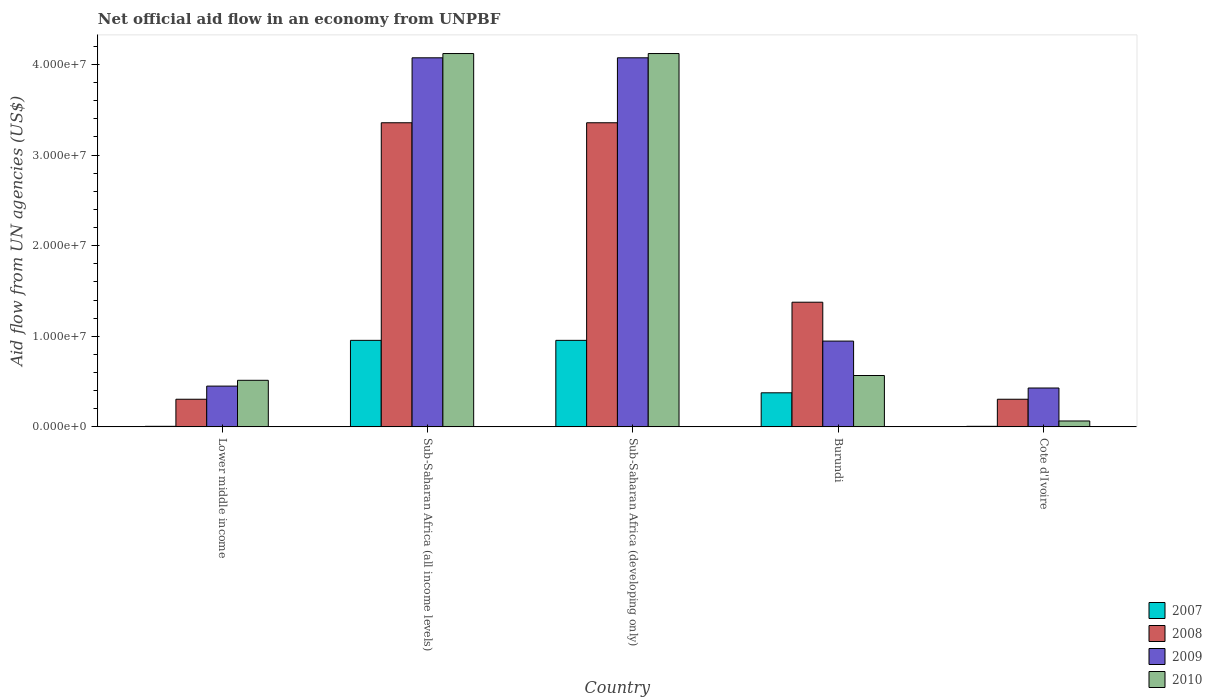Are the number of bars per tick equal to the number of legend labels?
Make the answer very short. Yes. Are the number of bars on each tick of the X-axis equal?
Your answer should be compact. Yes. How many bars are there on the 5th tick from the right?
Make the answer very short. 4. What is the label of the 3rd group of bars from the left?
Your answer should be very brief. Sub-Saharan Africa (developing only). In how many cases, is the number of bars for a given country not equal to the number of legend labels?
Provide a short and direct response. 0. What is the net official aid flow in 2009 in Burundi?
Offer a terse response. 9.47e+06. Across all countries, what is the maximum net official aid flow in 2009?
Your answer should be very brief. 4.07e+07. Across all countries, what is the minimum net official aid flow in 2009?
Provide a short and direct response. 4.29e+06. In which country was the net official aid flow in 2009 maximum?
Give a very brief answer. Sub-Saharan Africa (all income levels). In which country was the net official aid flow in 2010 minimum?
Provide a succinct answer. Cote d'Ivoire. What is the total net official aid flow in 2010 in the graph?
Keep it short and to the point. 9.39e+07. What is the difference between the net official aid flow in 2009 in Lower middle income and that in Sub-Saharan Africa (all income levels)?
Offer a terse response. -3.62e+07. What is the difference between the net official aid flow in 2010 in Burundi and the net official aid flow in 2009 in Lower middle income?
Make the answer very short. 1.17e+06. What is the average net official aid flow in 2010 per country?
Ensure brevity in your answer.  1.88e+07. What is the difference between the net official aid flow of/in 2009 and net official aid flow of/in 2008 in Sub-Saharan Africa (developing only)?
Give a very brief answer. 7.17e+06. In how many countries, is the net official aid flow in 2008 greater than 28000000 US$?
Ensure brevity in your answer.  2. What is the ratio of the net official aid flow in 2008 in Burundi to that in Cote d'Ivoire?
Your answer should be very brief. 4.51. What is the difference between the highest and the second highest net official aid flow in 2008?
Make the answer very short. 1.98e+07. What is the difference between the highest and the lowest net official aid flow in 2007?
Your answer should be compact. 9.49e+06. In how many countries, is the net official aid flow in 2007 greater than the average net official aid flow in 2007 taken over all countries?
Your answer should be very brief. 2. Is it the case that in every country, the sum of the net official aid flow in 2008 and net official aid flow in 2007 is greater than the sum of net official aid flow in 2009 and net official aid flow in 2010?
Offer a very short reply. No. How many bars are there?
Make the answer very short. 20. Are the values on the major ticks of Y-axis written in scientific E-notation?
Offer a very short reply. Yes. Does the graph contain any zero values?
Your answer should be very brief. No. How are the legend labels stacked?
Provide a succinct answer. Vertical. What is the title of the graph?
Keep it short and to the point. Net official aid flow in an economy from UNPBF. Does "2007" appear as one of the legend labels in the graph?
Offer a terse response. Yes. What is the label or title of the Y-axis?
Give a very brief answer. Aid flow from UN agencies (US$). What is the Aid flow from UN agencies (US$) of 2008 in Lower middle income?
Keep it short and to the point. 3.05e+06. What is the Aid flow from UN agencies (US$) of 2009 in Lower middle income?
Provide a succinct answer. 4.50e+06. What is the Aid flow from UN agencies (US$) of 2010 in Lower middle income?
Keep it short and to the point. 5.14e+06. What is the Aid flow from UN agencies (US$) of 2007 in Sub-Saharan Africa (all income levels)?
Keep it short and to the point. 9.55e+06. What is the Aid flow from UN agencies (US$) of 2008 in Sub-Saharan Africa (all income levels)?
Make the answer very short. 3.36e+07. What is the Aid flow from UN agencies (US$) in 2009 in Sub-Saharan Africa (all income levels)?
Provide a short and direct response. 4.07e+07. What is the Aid flow from UN agencies (US$) of 2010 in Sub-Saharan Africa (all income levels)?
Your response must be concise. 4.12e+07. What is the Aid flow from UN agencies (US$) in 2007 in Sub-Saharan Africa (developing only)?
Your answer should be compact. 9.55e+06. What is the Aid flow from UN agencies (US$) in 2008 in Sub-Saharan Africa (developing only)?
Your answer should be compact. 3.36e+07. What is the Aid flow from UN agencies (US$) of 2009 in Sub-Saharan Africa (developing only)?
Make the answer very short. 4.07e+07. What is the Aid flow from UN agencies (US$) of 2010 in Sub-Saharan Africa (developing only)?
Provide a succinct answer. 4.12e+07. What is the Aid flow from UN agencies (US$) of 2007 in Burundi?
Ensure brevity in your answer.  3.76e+06. What is the Aid flow from UN agencies (US$) in 2008 in Burundi?
Keep it short and to the point. 1.38e+07. What is the Aid flow from UN agencies (US$) in 2009 in Burundi?
Ensure brevity in your answer.  9.47e+06. What is the Aid flow from UN agencies (US$) of 2010 in Burundi?
Make the answer very short. 5.67e+06. What is the Aid flow from UN agencies (US$) in 2008 in Cote d'Ivoire?
Provide a succinct answer. 3.05e+06. What is the Aid flow from UN agencies (US$) in 2009 in Cote d'Ivoire?
Your answer should be compact. 4.29e+06. What is the Aid flow from UN agencies (US$) of 2010 in Cote d'Ivoire?
Give a very brief answer. 6.50e+05. Across all countries, what is the maximum Aid flow from UN agencies (US$) in 2007?
Make the answer very short. 9.55e+06. Across all countries, what is the maximum Aid flow from UN agencies (US$) of 2008?
Your answer should be very brief. 3.36e+07. Across all countries, what is the maximum Aid flow from UN agencies (US$) of 2009?
Make the answer very short. 4.07e+07. Across all countries, what is the maximum Aid flow from UN agencies (US$) in 2010?
Ensure brevity in your answer.  4.12e+07. Across all countries, what is the minimum Aid flow from UN agencies (US$) in 2008?
Ensure brevity in your answer.  3.05e+06. Across all countries, what is the minimum Aid flow from UN agencies (US$) of 2009?
Provide a succinct answer. 4.29e+06. Across all countries, what is the minimum Aid flow from UN agencies (US$) of 2010?
Make the answer very short. 6.50e+05. What is the total Aid flow from UN agencies (US$) of 2007 in the graph?
Ensure brevity in your answer.  2.30e+07. What is the total Aid flow from UN agencies (US$) in 2008 in the graph?
Your response must be concise. 8.70e+07. What is the total Aid flow from UN agencies (US$) in 2009 in the graph?
Your answer should be very brief. 9.97e+07. What is the total Aid flow from UN agencies (US$) in 2010 in the graph?
Ensure brevity in your answer.  9.39e+07. What is the difference between the Aid flow from UN agencies (US$) in 2007 in Lower middle income and that in Sub-Saharan Africa (all income levels)?
Provide a short and direct response. -9.49e+06. What is the difference between the Aid flow from UN agencies (US$) in 2008 in Lower middle income and that in Sub-Saharan Africa (all income levels)?
Your answer should be compact. -3.05e+07. What is the difference between the Aid flow from UN agencies (US$) in 2009 in Lower middle income and that in Sub-Saharan Africa (all income levels)?
Provide a short and direct response. -3.62e+07. What is the difference between the Aid flow from UN agencies (US$) in 2010 in Lower middle income and that in Sub-Saharan Africa (all income levels)?
Keep it short and to the point. -3.61e+07. What is the difference between the Aid flow from UN agencies (US$) in 2007 in Lower middle income and that in Sub-Saharan Africa (developing only)?
Keep it short and to the point. -9.49e+06. What is the difference between the Aid flow from UN agencies (US$) of 2008 in Lower middle income and that in Sub-Saharan Africa (developing only)?
Your answer should be compact. -3.05e+07. What is the difference between the Aid flow from UN agencies (US$) of 2009 in Lower middle income and that in Sub-Saharan Africa (developing only)?
Your answer should be compact. -3.62e+07. What is the difference between the Aid flow from UN agencies (US$) of 2010 in Lower middle income and that in Sub-Saharan Africa (developing only)?
Your answer should be very brief. -3.61e+07. What is the difference between the Aid flow from UN agencies (US$) of 2007 in Lower middle income and that in Burundi?
Make the answer very short. -3.70e+06. What is the difference between the Aid flow from UN agencies (US$) of 2008 in Lower middle income and that in Burundi?
Provide a succinct answer. -1.07e+07. What is the difference between the Aid flow from UN agencies (US$) of 2009 in Lower middle income and that in Burundi?
Your answer should be very brief. -4.97e+06. What is the difference between the Aid flow from UN agencies (US$) of 2010 in Lower middle income and that in Burundi?
Your answer should be very brief. -5.30e+05. What is the difference between the Aid flow from UN agencies (US$) of 2007 in Lower middle income and that in Cote d'Ivoire?
Provide a short and direct response. 0. What is the difference between the Aid flow from UN agencies (US$) of 2008 in Lower middle income and that in Cote d'Ivoire?
Offer a very short reply. 0. What is the difference between the Aid flow from UN agencies (US$) of 2010 in Lower middle income and that in Cote d'Ivoire?
Provide a short and direct response. 4.49e+06. What is the difference between the Aid flow from UN agencies (US$) of 2007 in Sub-Saharan Africa (all income levels) and that in Sub-Saharan Africa (developing only)?
Offer a terse response. 0. What is the difference between the Aid flow from UN agencies (US$) in 2008 in Sub-Saharan Africa (all income levels) and that in Sub-Saharan Africa (developing only)?
Offer a terse response. 0. What is the difference between the Aid flow from UN agencies (US$) of 2007 in Sub-Saharan Africa (all income levels) and that in Burundi?
Your answer should be compact. 5.79e+06. What is the difference between the Aid flow from UN agencies (US$) of 2008 in Sub-Saharan Africa (all income levels) and that in Burundi?
Offer a terse response. 1.98e+07. What is the difference between the Aid flow from UN agencies (US$) in 2009 in Sub-Saharan Africa (all income levels) and that in Burundi?
Offer a terse response. 3.13e+07. What is the difference between the Aid flow from UN agencies (US$) in 2010 in Sub-Saharan Africa (all income levels) and that in Burundi?
Ensure brevity in your answer.  3.55e+07. What is the difference between the Aid flow from UN agencies (US$) of 2007 in Sub-Saharan Africa (all income levels) and that in Cote d'Ivoire?
Offer a very short reply. 9.49e+06. What is the difference between the Aid flow from UN agencies (US$) of 2008 in Sub-Saharan Africa (all income levels) and that in Cote d'Ivoire?
Make the answer very short. 3.05e+07. What is the difference between the Aid flow from UN agencies (US$) in 2009 in Sub-Saharan Africa (all income levels) and that in Cote d'Ivoire?
Offer a very short reply. 3.64e+07. What is the difference between the Aid flow from UN agencies (US$) in 2010 in Sub-Saharan Africa (all income levels) and that in Cote d'Ivoire?
Offer a very short reply. 4.06e+07. What is the difference between the Aid flow from UN agencies (US$) in 2007 in Sub-Saharan Africa (developing only) and that in Burundi?
Your answer should be compact. 5.79e+06. What is the difference between the Aid flow from UN agencies (US$) in 2008 in Sub-Saharan Africa (developing only) and that in Burundi?
Your response must be concise. 1.98e+07. What is the difference between the Aid flow from UN agencies (US$) of 2009 in Sub-Saharan Africa (developing only) and that in Burundi?
Offer a terse response. 3.13e+07. What is the difference between the Aid flow from UN agencies (US$) in 2010 in Sub-Saharan Africa (developing only) and that in Burundi?
Give a very brief answer. 3.55e+07. What is the difference between the Aid flow from UN agencies (US$) in 2007 in Sub-Saharan Africa (developing only) and that in Cote d'Ivoire?
Give a very brief answer. 9.49e+06. What is the difference between the Aid flow from UN agencies (US$) in 2008 in Sub-Saharan Africa (developing only) and that in Cote d'Ivoire?
Keep it short and to the point. 3.05e+07. What is the difference between the Aid flow from UN agencies (US$) of 2009 in Sub-Saharan Africa (developing only) and that in Cote d'Ivoire?
Make the answer very short. 3.64e+07. What is the difference between the Aid flow from UN agencies (US$) of 2010 in Sub-Saharan Africa (developing only) and that in Cote d'Ivoire?
Provide a short and direct response. 4.06e+07. What is the difference between the Aid flow from UN agencies (US$) in 2007 in Burundi and that in Cote d'Ivoire?
Offer a terse response. 3.70e+06. What is the difference between the Aid flow from UN agencies (US$) of 2008 in Burundi and that in Cote d'Ivoire?
Give a very brief answer. 1.07e+07. What is the difference between the Aid flow from UN agencies (US$) in 2009 in Burundi and that in Cote d'Ivoire?
Make the answer very short. 5.18e+06. What is the difference between the Aid flow from UN agencies (US$) of 2010 in Burundi and that in Cote d'Ivoire?
Provide a succinct answer. 5.02e+06. What is the difference between the Aid flow from UN agencies (US$) in 2007 in Lower middle income and the Aid flow from UN agencies (US$) in 2008 in Sub-Saharan Africa (all income levels)?
Offer a very short reply. -3.35e+07. What is the difference between the Aid flow from UN agencies (US$) of 2007 in Lower middle income and the Aid flow from UN agencies (US$) of 2009 in Sub-Saharan Africa (all income levels)?
Offer a terse response. -4.07e+07. What is the difference between the Aid flow from UN agencies (US$) in 2007 in Lower middle income and the Aid flow from UN agencies (US$) in 2010 in Sub-Saharan Africa (all income levels)?
Offer a very short reply. -4.12e+07. What is the difference between the Aid flow from UN agencies (US$) of 2008 in Lower middle income and the Aid flow from UN agencies (US$) of 2009 in Sub-Saharan Africa (all income levels)?
Give a very brief answer. -3.77e+07. What is the difference between the Aid flow from UN agencies (US$) of 2008 in Lower middle income and the Aid flow from UN agencies (US$) of 2010 in Sub-Saharan Africa (all income levels)?
Offer a very short reply. -3.82e+07. What is the difference between the Aid flow from UN agencies (US$) in 2009 in Lower middle income and the Aid flow from UN agencies (US$) in 2010 in Sub-Saharan Africa (all income levels)?
Your response must be concise. -3.67e+07. What is the difference between the Aid flow from UN agencies (US$) in 2007 in Lower middle income and the Aid flow from UN agencies (US$) in 2008 in Sub-Saharan Africa (developing only)?
Your answer should be very brief. -3.35e+07. What is the difference between the Aid flow from UN agencies (US$) of 2007 in Lower middle income and the Aid flow from UN agencies (US$) of 2009 in Sub-Saharan Africa (developing only)?
Offer a very short reply. -4.07e+07. What is the difference between the Aid flow from UN agencies (US$) of 2007 in Lower middle income and the Aid flow from UN agencies (US$) of 2010 in Sub-Saharan Africa (developing only)?
Your answer should be very brief. -4.12e+07. What is the difference between the Aid flow from UN agencies (US$) of 2008 in Lower middle income and the Aid flow from UN agencies (US$) of 2009 in Sub-Saharan Africa (developing only)?
Your answer should be very brief. -3.77e+07. What is the difference between the Aid flow from UN agencies (US$) in 2008 in Lower middle income and the Aid flow from UN agencies (US$) in 2010 in Sub-Saharan Africa (developing only)?
Provide a succinct answer. -3.82e+07. What is the difference between the Aid flow from UN agencies (US$) of 2009 in Lower middle income and the Aid flow from UN agencies (US$) of 2010 in Sub-Saharan Africa (developing only)?
Your response must be concise. -3.67e+07. What is the difference between the Aid flow from UN agencies (US$) in 2007 in Lower middle income and the Aid flow from UN agencies (US$) in 2008 in Burundi?
Offer a terse response. -1.37e+07. What is the difference between the Aid flow from UN agencies (US$) in 2007 in Lower middle income and the Aid flow from UN agencies (US$) in 2009 in Burundi?
Offer a very short reply. -9.41e+06. What is the difference between the Aid flow from UN agencies (US$) in 2007 in Lower middle income and the Aid flow from UN agencies (US$) in 2010 in Burundi?
Provide a succinct answer. -5.61e+06. What is the difference between the Aid flow from UN agencies (US$) of 2008 in Lower middle income and the Aid flow from UN agencies (US$) of 2009 in Burundi?
Your answer should be very brief. -6.42e+06. What is the difference between the Aid flow from UN agencies (US$) of 2008 in Lower middle income and the Aid flow from UN agencies (US$) of 2010 in Burundi?
Keep it short and to the point. -2.62e+06. What is the difference between the Aid flow from UN agencies (US$) of 2009 in Lower middle income and the Aid flow from UN agencies (US$) of 2010 in Burundi?
Provide a short and direct response. -1.17e+06. What is the difference between the Aid flow from UN agencies (US$) in 2007 in Lower middle income and the Aid flow from UN agencies (US$) in 2008 in Cote d'Ivoire?
Your answer should be compact. -2.99e+06. What is the difference between the Aid flow from UN agencies (US$) of 2007 in Lower middle income and the Aid flow from UN agencies (US$) of 2009 in Cote d'Ivoire?
Provide a succinct answer. -4.23e+06. What is the difference between the Aid flow from UN agencies (US$) of 2007 in Lower middle income and the Aid flow from UN agencies (US$) of 2010 in Cote d'Ivoire?
Offer a very short reply. -5.90e+05. What is the difference between the Aid flow from UN agencies (US$) of 2008 in Lower middle income and the Aid flow from UN agencies (US$) of 2009 in Cote d'Ivoire?
Your answer should be compact. -1.24e+06. What is the difference between the Aid flow from UN agencies (US$) of 2008 in Lower middle income and the Aid flow from UN agencies (US$) of 2010 in Cote d'Ivoire?
Provide a short and direct response. 2.40e+06. What is the difference between the Aid flow from UN agencies (US$) of 2009 in Lower middle income and the Aid flow from UN agencies (US$) of 2010 in Cote d'Ivoire?
Offer a terse response. 3.85e+06. What is the difference between the Aid flow from UN agencies (US$) in 2007 in Sub-Saharan Africa (all income levels) and the Aid flow from UN agencies (US$) in 2008 in Sub-Saharan Africa (developing only)?
Make the answer very short. -2.40e+07. What is the difference between the Aid flow from UN agencies (US$) in 2007 in Sub-Saharan Africa (all income levels) and the Aid flow from UN agencies (US$) in 2009 in Sub-Saharan Africa (developing only)?
Ensure brevity in your answer.  -3.12e+07. What is the difference between the Aid flow from UN agencies (US$) in 2007 in Sub-Saharan Africa (all income levels) and the Aid flow from UN agencies (US$) in 2010 in Sub-Saharan Africa (developing only)?
Your answer should be compact. -3.17e+07. What is the difference between the Aid flow from UN agencies (US$) in 2008 in Sub-Saharan Africa (all income levels) and the Aid flow from UN agencies (US$) in 2009 in Sub-Saharan Africa (developing only)?
Make the answer very short. -7.17e+06. What is the difference between the Aid flow from UN agencies (US$) in 2008 in Sub-Saharan Africa (all income levels) and the Aid flow from UN agencies (US$) in 2010 in Sub-Saharan Africa (developing only)?
Ensure brevity in your answer.  -7.64e+06. What is the difference between the Aid flow from UN agencies (US$) in 2009 in Sub-Saharan Africa (all income levels) and the Aid flow from UN agencies (US$) in 2010 in Sub-Saharan Africa (developing only)?
Keep it short and to the point. -4.70e+05. What is the difference between the Aid flow from UN agencies (US$) of 2007 in Sub-Saharan Africa (all income levels) and the Aid flow from UN agencies (US$) of 2008 in Burundi?
Keep it short and to the point. -4.21e+06. What is the difference between the Aid flow from UN agencies (US$) of 2007 in Sub-Saharan Africa (all income levels) and the Aid flow from UN agencies (US$) of 2010 in Burundi?
Keep it short and to the point. 3.88e+06. What is the difference between the Aid flow from UN agencies (US$) of 2008 in Sub-Saharan Africa (all income levels) and the Aid flow from UN agencies (US$) of 2009 in Burundi?
Provide a short and direct response. 2.41e+07. What is the difference between the Aid flow from UN agencies (US$) of 2008 in Sub-Saharan Africa (all income levels) and the Aid flow from UN agencies (US$) of 2010 in Burundi?
Provide a succinct answer. 2.79e+07. What is the difference between the Aid flow from UN agencies (US$) of 2009 in Sub-Saharan Africa (all income levels) and the Aid flow from UN agencies (US$) of 2010 in Burundi?
Offer a terse response. 3.51e+07. What is the difference between the Aid flow from UN agencies (US$) of 2007 in Sub-Saharan Africa (all income levels) and the Aid flow from UN agencies (US$) of 2008 in Cote d'Ivoire?
Provide a short and direct response. 6.50e+06. What is the difference between the Aid flow from UN agencies (US$) in 2007 in Sub-Saharan Africa (all income levels) and the Aid flow from UN agencies (US$) in 2009 in Cote d'Ivoire?
Keep it short and to the point. 5.26e+06. What is the difference between the Aid flow from UN agencies (US$) in 2007 in Sub-Saharan Africa (all income levels) and the Aid flow from UN agencies (US$) in 2010 in Cote d'Ivoire?
Ensure brevity in your answer.  8.90e+06. What is the difference between the Aid flow from UN agencies (US$) of 2008 in Sub-Saharan Africa (all income levels) and the Aid flow from UN agencies (US$) of 2009 in Cote d'Ivoire?
Provide a succinct answer. 2.93e+07. What is the difference between the Aid flow from UN agencies (US$) in 2008 in Sub-Saharan Africa (all income levels) and the Aid flow from UN agencies (US$) in 2010 in Cote d'Ivoire?
Make the answer very short. 3.29e+07. What is the difference between the Aid flow from UN agencies (US$) of 2009 in Sub-Saharan Africa (all income levels) and the Aid flow from UN agencies (US$) of 2010 in Cote d'Ivoire?
Give a very brief answer. 4.01e+07. What is the difference between the Aid flow from UN agencies (US$) of 2007 in Sub-Saharan Africa (developing only) and the Aid flow from UN agencies (US$) of 2008 in Burundi?
Your answer should be very brief. -4.21e+06. What is the difference between the Aid flow from UN agencies (US$) of 2007 in Sub-Saharan Africa (developing only) and the Aid flow from UN agencies (US$) of 2009 in Burundi?
Keep it short and to the point. 8.00e+04. What is the difference between the Aid flow from UN agencies (US$) of 2007 in Sub-Saharan Africa (developing only) and the Aid flow from UN agencies (US$) of 2010 in Burundi?
Offer a terse response. 3.88e+06. What is the difference between the Aid flow from UN agencies (US$) of 2008 in Sub-Saharan Africa (developing only) and the Aid flow from UN agencies (US$) of 2009 in Burundi?
Offer a very short reply. 2.41e+07. What is the difference between the Aid flow from UN agencies (US$) in 2008 in Sub-Saharan Africa (developing only) and the Aid flow from UN agencies (US$) in 2010 in Burundi?
Keep it short and to the point. 2.79e+07. What is the difference between the Aid flow from UN agencies (US$) in 2009 in Sub-Saharan Africa (developing only) and the Aid flow from UN agencies (US$) in 2010 in Burundi?
Your answer should be compact. 3.51e+07. What is the difference between the Aid flow from UN agencies (US$) in 2007 in Sub-Saharan Africa (developing only) and the Aid flow from UN agencies (US$) in 2008 in Cote d'Ivoire?
Your response must be concise. 6.50e+06. What is the difference between the Aid flow from UN agencies (US$) of 2007 in Sub-Saharan Africa (developing only) and the Aid flow from UN agencies (US$) of 2009 in Cote d'Ivoire?
Your answer should be very brief. 5.26e+06. What is the difference between the Aid flow from UN agencies (US$) in 2007 in Sub-Saharan Africa (developing only) and the Aid flow from UN agencies (US$) in 2010 in Cote d'Ivoire?
Ensure brevity in your answer.  8.90e+06. What is the difference between the Aid flow from UN agencies (US$) of 2008 in Sub-Saharan Africa (developing only) and the Aid flow from UN agencies (US$) of 2009 in Cote d'Ivoire?
Give a very brief answer. 2.93e+07. What is the difference between the Aid flow from UN agencies (US$) in 2008 in Sub-Saharan Africa (developing only) and the Aid flow from UN agencies (US$) in 2010 in Cote d'Ivoire?
Keep it short and to the point. 3.29e+07. What is the difference between the Aid flow from UN agencies (US$) of 2009 in Sub-Saharan Africa (developing only) and the Aid flow from UN agencies (US$) of 2010 in Cote d'Ivoire?
Give a very brief answer. 4.01e+07. What is the difference between the Aid flow from UN agencies (US$) of 2007 in Burundi and the Aid flow from UN agencies (US$) of 2008 in Cote d'Ivoire?
Provide a short and direct response. 7.10e+05. What is the difference between the Aid flow from UN agencies (US$) of 2007 in Burundi and the Aid flow from UN agencies (US$) of 2009 in Cote d'Ivoire?
Provide a succinct answer. -5.30e+05. What is the difference between the Aid flow from UN agencies (US$) in 2007 in Burundi and the Aid flow from UN agencies (US$) in 2010 in Cote d'Ivoire?
Offer a terse response. 3.11e+06. What is the difference between the Aid flow from UN agencies (US$) of 2008 in Burundi and the Aid flow from UN agencies (US$) of 2009 in Cote d'Ivoire?
Provide a succinct answer. 9.47e+06. What is the difference between the Aid flow from UN agencies (US$) in 2008 in Burundi and the Aid flow from UN agencies (US$) in 2010 in Cote d'Ivoire?
Keep it short and to the point. 1.31e+07. What is the difference between the Aid flow from UN agencies (US$) of 2009 in Burundi and the Aid flow from UN agencies (US$) of 2010 in Cote d'Ivoire?
Your answer should be compact. 8.82e+06. What is the average Aid flow from UN agencies (US$) in 2007 per country?
Keep it short and to the point. 4.60e+06. What is the average Aid flow from UN agencies (US$) of 2008 per country?
Offer a very short reply. 1.74e+07. What is the average Aid flow from UN agencies (US$) in 2009 per country?
Provide a short and direct response. 1.99e+07. What is the average Aid flow from UN agencies (US$) of 2010 per country?
Provide a short and direct response. 1.88e+07. What is the difference between the Aid flow from UN agencies (US$) of 2007 and Aid flow from UN agencies (US$) of 2008 in Lower middle income?
Keep it short and to the point. -2.99e+06. What is the difference between the Aid flow from UN agencies (US$) in 2007 and Aid flow from UN agencies (US$) in 2009 in Lower middle income?
Offer a very short reply. -4.44e+06. What is the difference between the Aid flow from UN agencies (US$) in 2007 and Aid flow from UN agencies (US$) in 2010 in Lower middle income?
Ensure brevity in your answer.  -5.08e+06. What is the difference between the Aid flow from UN agencies (US$) of 2008 and Aid flow from UN agencies (US$) of 2009 in Lower middle income?
Provide a short and direct response. -1.45e+06. What is the difference between the Aid flow from UN agencies (US$) in 2008 and Aid flow from UN agencies (US$) in 2010 in Lower middle income?
Provide a succinct answer. -2.09e+06. What is the difference between the Aid flow from UN agencies (US$) in 2009 and Aid flow from UN agencies (US$) in 2010 in Lower middle income?
Give a very brief answer. -6.40e+05. What is the difference between the Aid flow from UN agencies (US$) of 2007 and Aid flow from UN agencies (US$) of 2008 in Sub-Saharan Africa (all income levels)?
Offer a terse response. -2.40e+07. What is the difference between the Aid flow from UN agencies (US$) of 2007 and Aid flow from UN agencies (US$) of 2009 in Sub-Saharan Africa (all income levels)?
Make the answer very short. -3.12e+07. What is the difference between the Aid flow from UN agencies (US$) of 2007 and Aid flow from UN agencies (US$) of 2010 in Sub-Saharan Africa (all income levels)?
Your answer should be compact. -3.17e+07. What is the difference between the Aid flow from UN agencies (US$) of 2008 and Aid flow from UN agencies (US$) of 2009 in Sub-Saharan Africa (all income levels)?
Make the answer very short. -7.17e+06. What is the difference between the Aid flow from UN agencies (US$) of 2008 and Aid flow from UN agencies (US$) of 2010 in Sub-Saharan Africa (all income levels)?
Provide a short and direct response. -7.64e+06. What is the difference between the Aid flow from UN agencies (US$) of 2009 and Aid flow from UN agencies (US$) of 2010 in Sub-Saharan Africa (all income levels)?
Ensure brevity in your answer.  -4.70e+05. What is the difference between the Aid flow from UN agencies (US$) in 2007 and Aid flow from UN agencies (US$) in 2008 in Sub-Saharan Africa (developing only)?
Your answer should be compact. -2.40e+07. What is the difference between the Aid flow from UN agencies (US$) in 2007 and Aid flow from UN agencies (US$) in 2009 in Sub-Saharan Africa (developing only)?
Make the answer very short. -3.12e+07. What is the difference between the Aid flow from UN agencies (US$) of 2007 and Aid flow from UN agencies (US$) of 2010 in Sub-Saharan Africa (developing only)?
Provide a succinct answer. -3.17e+07. What is the difference between the Aid flow from UN agencies (US$) in 2008 and Aid flow from UN agencies (US$) in 2009 in Sub-Saharan Africa (developing only)?
Your response must be concise. -7.17e+06. What is the difference between the Aid flow from UN agencies (US$) of 2008 and Aid flow from UN agencies (US$) of 2010 in Sub-Saharan Africa (developing only)?
Make the answer very short. -7.64e+06. What is the difference between the Aid flow from UN agencies (US$) in 2009 and Aid flow from UN agencies (US$) in 2010 in Sub-Saharan Africa (developing only)?
Offer a terse response. -4.70e+05. What is the difference between the Aid flow from UN agencies (US$) in 2007 and Aid flow from UN agencies (US$) in 2008 in Burundi?
Give a very brief answer. -1.00e+07. What is the difference between the Aid flow from UN agencies (US$) in 2007 and Aid flow from UN agencies (US$) in 2009 in Burundi?
Your response must be concise. -5.71e+06. What is the difference between the Aid flow from UN agencies (US$) of 2007 and Aid flow from UN agencies (US$) of 2010 in Burundi?
Make the answer very short. -1.91e+06. What is the difference between the Aid flow from UN agencies (US$) of 2008 and Aid flow from UN agencies (US$) of 2009 in Burundi?
Offer a terse response. 4.29e+06. What is the difference between the Aid flow from UN agencies (US$) of 2008 and Aid flow from UN agencies (US$) of 2010 in Burundi?
Make the answer very short. 8.09e+06. What is the difference between the Aid flow from UN agencies (US$) in 2009 and Aid flow from UN agencies (US$) in 2010 in Burundi?
Provide a short and direct response. 3.80e+06. What is the difference between the Aid flow from UN agencies (US$) in 2007 and Aid flow from UN agencies (US$) in 2008 in Cote d'Ivoire?
Offer a terse response. -2.99e+06. What is the difference between the Aid flow from UN agencies (US$) of 2007 and Aid flow from UN agencies (US$) of 2009 in Cote d'Ivoire?
Provide a succinct answer. -4.23e+06. What is the difference between the Aid flow from UN agencies (US$) of 2007 and Aid flow from UN agencies (US$) of 2010 in Cote d'Ivoire?
Provide a short and direct response. -5.90e+05. What is the difference between the Aid flow from UN agencies (US$) in 2008 and Aid flow from UN agencies (US$) in 2009 in Cote d'Ivoire?
Offer a very short reply. -1.24e+06. What is the difference between the Aid flow from UN agencies (US$) of 2008 and Aid flow from UN agencies (US$) of 2010 in Cote d'Ivoire?
Offer a very short reply. 2.40e+06. What is the difference between the Aid flow from UN agencies (US$) of 2009 and Aid flow from UN agencies (US$) of 2010 in Cote d'Ivoire?
Make the answer very short. 3.64e+06. What is the ratio of the Aid flow from UN agencies (US$) in 2007 in Lower middle income to that in Sub-Saharan Africa (all income levels)?
Keep it short and to the point. 0.01. What is the ratio of the Aid flow from UN agencies (US$) of 2008 in Lower middle income to that in Sub-Saharan Africa (all income levels)?
Your response must be concise. 0.09. What is the ratio of the Aid flow from UN agencies (US$) of 2009 in Lower middle income to that in Sub-Saharan Africa (all income levels)?
Offer a very short reply. 0.11. What is the ratio of the Aid flow from UN agencies (US$) in 2010 in Lower middle income to that in Sub-Saharan Africa (all income levels)?
Offer a terse response. 0.12. What is the ratio of the Aid flow from UN agencies (US$) of 2007 in Lower middle income to that in Sub-Saharan Africa (developing only)?
Ensure brevity in your answer.  0.01. What is the ratio of the Aid flow from UN agencies (US$) in 2008 in Lower middle income to that in Sub-Saharan Africa (developing only)?
Your answer should be very brief. 0.09. What is the ratio of the Aid flow from UN agencies (US$) in 2009 in Lower middle income to that in Sub-Saharan Africa (developing only)?
Make the answer very short. 0.11. What is the ratio of the Aid flow from UN agencies (US$) in 2010 in Lower middle income to that in Sub-Saharan Africa (developing only)?
Give a very brief answer. 0.12. What is the ratio of the Aid flow from UN agencies (US$) in 2007 in Lower middle income to that in Burundi?
Provide a succinct answer. 0.02. What is the ratio of the Aid flow from UN agencies (US$) of 2008 in Lower middle income to that in Burundi?
Provide a succinct answer. 0.22. What is the ratio of the Aid flow from UN agencies (US$) of 2009 in Lower middle income to that in Burundi?
Make the answer very short. 0.48. What is the ratio of the Aid flow from UN agencies (US$) in 2010 in Lower middle income to that in Burundi?
Offer a terse response. 0.91. What is the ratio of the Aid flow from UN agencies (US$) of 2009 in Lower middle income to that in Cote d'Ivoire?
Give a very brief answer. 1.05. What is the ratio of the Aid flow from UN agencies (US$) of 2010 in Lower middle income to that in Cote d'Ivoire?
Your answer should be compact. 7.91. What is the ratio of the Aid flow from UN agencies (US$) of 2007 in Sub-Saharan Africa (all income levels) to that in Sub-Saharan Africa (developing only)?
Offer a terse response. 1. What is the ratio of the Aid flow from UN agencies (US$) of 2008 in Sub-Saharan Africa (all income levels) to that in Sub-Saharan Africa (developing only)?
Provide a succinct answer. 1. What is the ratio of the Aid flow from UN agencies (US$) in 2009 in Sub-Saharan Africa (all income levels) to that in Sub-Saharan Africa (developing only)?
Keep it short and to the point. 1. What is the ratio of the Aid flow from UN agencies (US$) in 2007 in Sub-Saharan Africa (all income levels) to that in Burundi?
Your answer should be compact. 2.54. What is the ratio of the Aid flow from UN agencies (US$) in 2008 in Sub-Saharan Africa (all income levels) to that in Burundi?
Provide a succinct answer. 2.44. What is the ratio of the Aid flow from UN agencies (US$) of 2009 in Sub-Saharan Africa (all income levels) to that in Burundi?
Keep it short and to the point. 4.3. What is the ratio of the Aid flow from UN agencies (US$) in 2010 in Sub-Saharan Africa (all income levels) to that in Burundi?
Provide a short and direct response. 7.27. What is the ratio of the Aid flow from UN agencies (US$) of 2007 in Sub-Saharan Africa (all income levels) to that in Cote d'Ivoire?
Give a very brief answer. 159.17. What is the ratio of the Aid flow from UN agencies (US$) of 2008 in Sub-Saharan Africa (all income levels) to that in Cote d'Ivoire?
Make the answer very short. 11.01. What is the ratio of the Aid flow from UN agencies (US$) in 2009 in Sub-Saharan Africa (all income levels) to that in Cote d'Ivoire?
Your answer should be compact. 9.5. What is the ratio of the Aid flow from UN agencies (US$) of 2010 in Sub-Saharan Africa (all income levels) to that in Cote d'Ivoire?
Keep it short and to the point. 63.4. What is the ratio of the Aid flow from UN agencies (US$) in 2007 in Sub-Saharan Africa (developing only) to that in Burundi?
Your answer should be compact. 2.54. What is the ratio of the Aid flow from UN agencies (US$) of 2008 in Sub-Saharan Africa (developing only) to that in Burundi?
Keep it short and to the point. 2.44. What is the ratio of the Aid flow from UN agencies (US$) in 2009 in Sub-Saharan Africa (developing only) to that in Burundi?
Provide a short and direct response. 4.3. What is the ratio of the Aid flow from UN agencies (US$) of 2010 in Sub-Saharan Africa (developing only) to that in Burundi?
Your answer should be compact. 7.27. What is the ratio of the Aid flow from UN agencies (US$) in 2007 in Sub-Saharan Africa (developing only) to that in Cote d'Ivoire?
Your answer should be very brief. 159.17. What is the ratio of the Aid flow from UN agencies (US$) of 2008 in Sub-Saharan Africa (developing only) to that in Cote d'Ivoire?
Provide a short and direct response. 11.01. What is the ratio of the Aid flow from UN agencies (US$) of 2009 in Sub-Saharan Africa (developing only) to that in Cote d'Ivoire?
Make the answer very short. 9.5. What is the ratio of the Aid flow from UN agencies (US$) of 2010 in Sub-Saharan Africa (developing only) to that in Cote d'Ivoire?
Make the answer very short. 63.4. What is the ratio of the Aid flow from UN agencies (US$) of 2007 in Burundi to that in Cote d'Ivoire?
Ensure brevity in your answer.  62.67. What is the ratio of the Aid flow from UN agencies (US$) of 2008 in Burundi to that in Cote d'Ivoire?
Your answer should be compact. 4.51. What is the ratio of the Aid flow from UN agencies (US$) of 2009 in Burundi to that in Cote d'Ivoire?
Make the answer very short. 2.21. What is the ratio of the Aid flow from UN agencies (US$) in 2010 in Burundi to that in Cote d'Ivoire?
Offer a very short reply. 8.72. What is the difference between the highest and the second highest Aid flow from UN agencies (US$) of 2009?
Your response must be concise. 0. What is the difference between the highest and the lowest Aid flow from UN agencies (US$) of 2007?
Provide a succinct answer. 9.49e+06. What is the difference between the highest and the lowest Aid flow from UN agencies (US$) in 2008?
Make the answer very short. 3.05e+07. What is the difference between the highest and the lowest Aid flow from UN agencies (US$) of 2009?
Give a very brief answer. 3.64e+07. What is the difference between the highest and the lowest Aid flow from UN agencies (US$) of 2010?
Your response must be concise. 4.06e+07. 